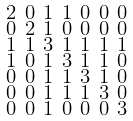<formula> <loc_0><loc_0><loc_500><loc_500>\begin{smallmatrix} 2 & 0 & 1 & 1 & 0 & 0 & 0 \\ 0 & 2 & 1 & 0 & 0 & 0 & 0 \\ 1 & 1 & 3 & 1 & 1 & 1 & 1 \\ 1 & 0 & 1 & 3 & 1 & 1 & 0 \\ 0 & 0 & 1 & 1 & 3 & 1 & 0 \\ 0 & 0 & 1 & 1 & 1 & 3 & 0 \\ 0 & 0 & 1 & 0 & 0 & 0 & 3 \end{smallmatrix}</formula> 